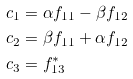Convert formula to latex. <formula><loc_0><loc_0><loc_500><loc_500>c _ { 1 } & = \alpha f _ { 1 1 } - \beta f _ { 1 2 } \\ c _ { 2 } & = \beta f _ { 1 1 } + \alpha f _ { 1 2 } \\ c _ { 3 } & = f _ { 1 3 } ^ { * }</formula> 